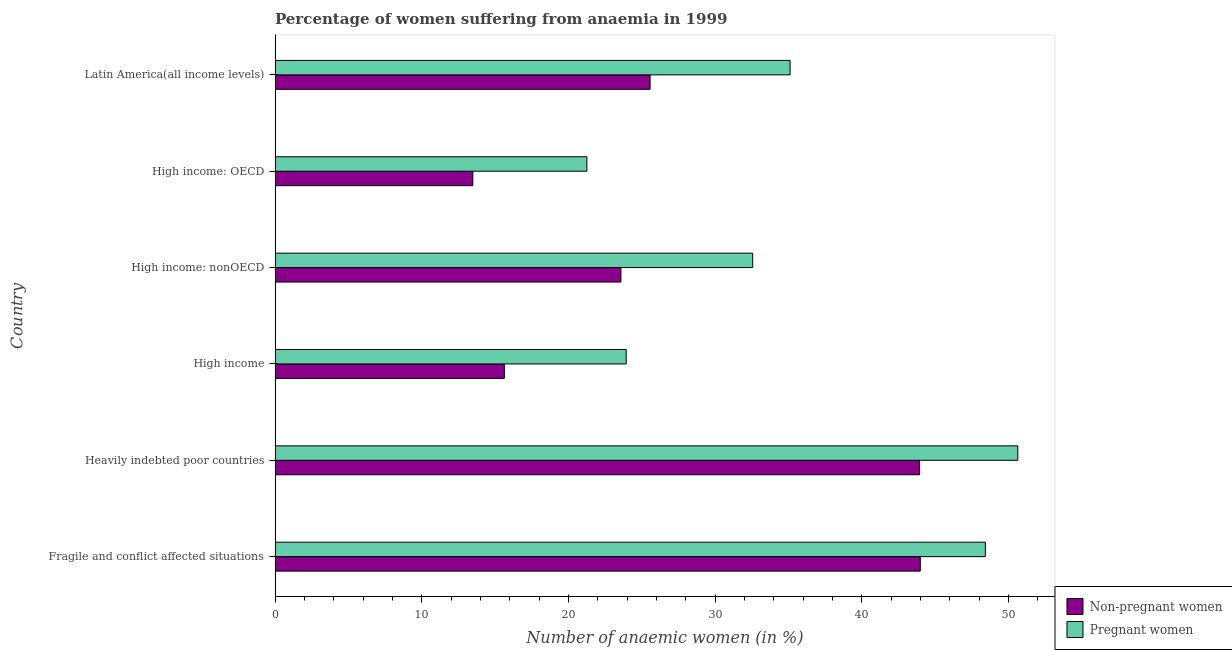How many groups of bars are there?
Make the answer very short. 6. Are the number of bars on each tick of the Y-axis equal?
Provide a short and direct response. Yes. What is the label of the 5th group of bars from the top?
Your response must be concise. Heavily indebted poor countries. What is the percentage of pregnant anaemic women in High income: OECD?
Your response must be concise. 21.26. Across all countries, what is the maximum percentage of non-pregnant anaemic women?
Make the answer very short. 44. Across all countries, what is the minimum percentage of pregnant anaemic women?
Give a very brief answer. 21.26. In which country was the percentage of pregnant anaemic women maximum?
Keep it short and to the point. Heavily indebted poor countries. In which country was the percentage of pregnant anaemic women minimum?
Offer a very short reply. High income: OECD. What is the total percentage of pregnant anaemic women in the graph?
Provide a succinct answer. 211.97. What is the difference between the percentage of pregnant anaemic women in Fragile and conflict affected situations and that in High income: nonOECD?
Your response must be concise. 15.87. What is the difference between the percentage of non-pregnant anaemic women in Heavily indebted poor countries and the percentage of pregnant anaemic women in Fragile and conflict affected situations?
Provide a short and direct response. -4.48. What is the average percentage of pregnant anaemic women per country?
Ensure brevity in your answer.  35.33. What is the difference between the percentage of non-pregnant anaemic women and percentage of pregnant anaemic women in High income: OECD?
Offer a very short reply. -7.78. In how many countries, is the percentage of non-pregnant anaemic women greater than 44 %?
Provide a succinct answer. 0. What is the ratio of the percentage of pregnant anaemic women in High income to that in Latin America(all income levels)?
Your answer should be very brief. 0.68. Is the percentage of pregnant anaemic women in Fragile and conflict affected situations less than that in Heavily indebted poor countries?
Offer a terse response. Yes. What is the difference between the highest and the second highest percentage of non-pregnant anaemic women?
Give a very brief answer. 0.05. What is the difference between the highest and the lowest percentage of pregnant anaemic women?
Your response must be concise. 29.39. In how many countries, is the percentage of non-pregnant anaemic women greater than the average percentage of non-pregnant anaemic women taken over all countries?
Your response must be concise. 2. What does the 2nd bar from the top in High income: OECD represents?
Ensure brevity in your answer.  Non-pregnant women. What does the 1st bar from the bottom in High income: nonOECD represents?
Keep it short and to the point. Non-pregnant women. How many bars are there?
Ensure brevity in your answer.  12. How many countries are there in the graph?
Offer a very short reply. 6. What is the difference between two consecutive major ticks on the X-axis?
Give a very brief answer. 10. Are the values on the major ticks of X-axis written in scientific E-notation?
Offer a terse response. No. Does the graph contain grids?
Your answer should be compact. No. Where does the legend appear in the graph?
Keep it short and to the point. Bottom right. How are the legend labels stacked?
Keep it short and to the point. Vertical. What is the title of the graph?
Provide a succinct answer. Percentage of women suffering from anaemia in 1999. Does "Secondary" appear as one of the legend labels in the graph?
Ensure brevity in your answer.  No. What is the label or title of the X-axis?
Ensure brevity in your answer.  Number of anaemic women (in %). What is the Number of anaemic women (in %) in Non-pregnant women in Fragile and conflict affected situations?
Give a very brief answer. 44. What is the Number of anaemic women (in %) in Pregnant women in Fragile and conflict affected situations?
Provide a short and direct response. 48.43. What is the Number of anaemic women (in %) in Non-pregnant women in Heavily indebted poor countries?
Give a very brief answer. 43.95. What is the Number of anaemic women (in %) in Pregnant women in Heavily indebted poor countries?
Make the answer very short. 50.65. What is the Number of anaemic women (in %) in Non-pregnant women in High income?
Make the answer very short. 15.63. What is the Number of anaemic women (in %) of Pregnant women in High income?
Your response must be concise. 23.94. What is the Number of anaemic women (in %) of Non-pregnant women in High income: nonOECD?
Give a very brief answer. 23.58. What is the Number of anaemic women (in %) in Pregnant women in High income: nonOECD?
Make the answer very short. 32.57. What is the Number of anaemic women (in %) of Non-pregnant women in High income: OECD?
Make the answer very short. 13.48. What is the Number of anaemic women (in %) in Pregnant women in High income: OECD?
Offer a very short reply. 21.26. What is the Number of anaemic women (in %) of Non-pregnant women in Latin America(all income levels)?
Offer a terse response. 25.57. What is the Number of anaemic women (in %) in Pregnant women in Latin America(all income levels)?
Make the answer very short. 35.12. Across all countries, what is the maximum Number of anaemic women (in %) in Non-pregnant women?
Provide a succinct answer. 44. Across all countries, what is the maximum Number of anaemic women (in %) of Pregnant women?
Keep it short and to the point. 50.65. Across all countries, what is the minimum Number of anaemic women (in %) of Non-pregnant women?
Provide a succinct answer. 13.48. Across all countries, what is the minimum Number of anaemic women (in %) in Pregnant women?
Provide a succinct answer. 21.26. What is the total Number of anaemic women (in %) of Non-pregnant women in the graph?
Make the answer very short. 166.22. What is the total Number of anaemic women (in %) of Pregnant women in the graph?
Offer a very short reply. 211.97. What is the difference between the Number of anaemic women (in %) of Non-pregnant women in Fragile and conflict affected situations and that in Heavily indebted poor countries?
Make the answer very short. 0.05. What is the difference between the Number of anaemic women (in %) of Pregnant women in Fragile and conflict affected situations and that in Heavily indebted poor countries?
Give a very brief answer. -2.21. What is the difference between the Number of anaemic women (in %) of Non-pregnant women in Fragile and conflict affected situations and that in High income?
Your answer should be compact. 28.36. What is the difference between the Number of anaemic women (in %) of Pregnant women in Fragile and conflict affected situations and that in High income?
Ensure brevity in your answer.  24.49. What is the difference between the Number of anaemic women (in %) of Non-pregnant women in Fragile and conflict affected situations and that in High income: nonOECD?
Keep it short and to the point. 20.41. What is the difference between the Number of anaemic women (in %) of Pregnant women in Fragile and conflict affected situations and that in High income: nonOECD?
Offer a very short reply. 15.86. What is the difference between the Number of anaemic women (in %) of Non-pregnant women in Fragile and conflict affected situations and that in High income: OECD?
Make the answer very short. 30.51. What is the difference between the Number of anaemic women (in %) of Pregnant women in Fragile and conflict affected situations and that in High income: OECD?
Your answer should be very brief. 27.17. What is the difference between the Number of anaemic women (in %) in Non-pregnant women in Fragile and conflict affected situations and that in Latin America(all income levels)?
Your response must be concise. 18.43. What is the difference between the Number of anaemic women (in %) in Pregnant women in Fragile and conflict affected situations and that in Latin America(all income levels)?
Your answer should be very brief. 13.31. What is the difference between the Number of anaemic women (in %) in Non-pregnant women in Heavily indebted poor countries and that in High income?
Offer a very short reply. 28.32. What is the difference between the Number of anaemic women (in %) in Pregnant women in Heavily indebted poor countries and that in High income?
Make the answer very short. 26.71. What is the difference between the Number of anaemic women (in %) of Non-pregnant women in Heavily indebted poor countries and that in High income: nonOECD?
Your answer should be very brief. 20.37. What is the difference between the Number of anaemic women (in %) in Pregnant women in Heavily indebted poor countries and that in High income: nonOECD?
Give a very brief answer. 18.08. What is the difference between the Number of anaemic women (in %) in Non-pregnant women in Heavily indebted poor countries and that in High income: OECD?
Offer a terse response. 30.47. What is the difference between the Number of anaemic women (in %) of Pregnant women in Heavily indebted poor countries and that in High income: OECD?
Offer a very short reply. 29.39. What is the difference between the Number of anaemic women (in %) of Non-pregnant women in Heavily indebted poor countries and that in Latin America(all income levels)?
Give a very brief answer. 18.38. What is the difference between the Number of anaemic women (in %) of Pregnant women in Heavily indebted poor countries and that in Latin America(all income levels)?
Provide a succinct answer. 15.53. What is the difference between the Number of anaemic women (in %) in Non-pregnant women in High income and that in High income: nonOECD?
Provide a succinct answer. -7.95. What is the difference between the Number of anaemic women (in %) in Pregnant women in High income and that in High income: nonOECD?
Offer a very short reply. -8.63. What is the difference between the Number of anaemic women (in %) of Non-pregnant women in High income and that in High income: OECD?
Your response must be concise. 2.15. What is the difference between the Number of anaemic women (in %) of Pregnant women in High income and that in High income: OECD?
Your response must be concise. 2.68. What is the difference between the Number of anaemic women (in %) in Non-pregnant women in High income and that in Latin America(all income levels)?
Provide a succinct answer. -9.94. What is the difference between the Number of anaemic women (in %) of Pregnant women in High income and that in Latin America(all income levels)?
Provide a succinct answer. -11.18. What is the difference between the Number of anaemic women (in %) of Non-pregnant women in High income: nonOECD and that in High income: OECD?
Make the answer very short. 10.1. What is the difference between the Number of anaemic women (in %) in Pregnant women in High income: nonOECD and that in High income: OECD?
Keep it short and to the point. 11.31. What is the difference between the Number of anaemic women (in %) of Non-pregnant women in High income: nonOECD and that in Latin America(all income levels)?
Keep it short and to the point. -1.99. What is the difference between the Number of anaemic women (in %) of Pregnant women in High income: nonOECD and that in Latin America(all income levels)?
Your answer should be very brief. -2.55. What is the difference between the Number of anaemic women (in %) in Non-pregnant women in High income: OECD and that in Latin America(all income levels)?
Offer a terse response. -12.09. What is the difference between the Number of anaemic women (in %) of Pregnant women in High income: OECD and that in Latin America(all income levels)?
Provide a short and direct response. -13.86. What is the difference between the Number of anaemic women (in %) in Non-pregnant women in Fragile and conflict affected situations and the Number of anaemic women (in %) in Pregnant women in Heavily indebted poor countries?
Your answer should be compact. -6.65. What is the difference between the Number of anaemic women (in %) in Non-pregnant women in Fragile and conflict affected situations and the Number of anaemic women (in %) in Pregnant women in High income?
Give a very brief answer. 20.05. What is the difference between the Number of anaemic women (in %) in Non-pregnant women in Fragile and conflict affected situations and the Number of anaemic women (in %) in Pregnant women in High income: nonOECD?
Provide a succinct answer. 11.43. What is the difference between the Number of anaemic women (in %) in Non-pregnant women in Fragile and conflict affected situations and the Number of anaemic women (in %) in Pregnant women in High income: OECD?
Your answer should be compact. 22.74. What is the difference between the Number of anaemic women (in %) of Non-pregnant women in Fragile and conflict affected situations and the Number of anaemic women (in %) of Pregnant women in Latin America(all income levels)?
Keep it short and to the point. 8.88. What is the difference between the Number of anaemic women (in %) of Non-pregnant women in Heavily indebted poor countries and the Number of anaemic women (in %) of Pregnant women in High income?
Provide a succinct answer. 20.01. What is the difference between the Number of anaemic women (in %) of Non-pregnant women in Heavily indebted poor countries and the Number of anaemic women (in %) of Pregnant women in High income: nonOECD?
Make the answer very short. 11.38. What is the difference between the Number of anaemic women (in %) of Non-pregnant women in Heavily indebted poor countries and the Number of anaemic women (in %) of Pregnant women in High income: OECD?
Make the answer very short. 22.69. What is the difference between the Number of anaemic women (in %) in Non-pregnant women in Heavily indebted poor countries and the Number of anaemic women (in %) in Pregnant women in Latin America(all income levels)?
Offer a terse response. 8.83. What is the difference between the Number of anaemic women (in %) in Non-pregnant women in High income and the Number of anaemic women (in %) in Pregnant women in High income: nonOECD?
Offer a very short reply. -16.94. What is the difference between the Number of anaemic women (in %) in Non-pregnant women in High income and the Number of anaemic women (in %) in Pregnant women in High income: OECD?
Your answer should be compact. -5.63. What is the difference between the Number of anaemic women (in %) of Non-pregnant women in High income and the Number of anaemic women (in %) of Pregnant women in Latin America(all income levels)?
Make the answer very short. -19.49. What is the difference between the Number of anaemic women (in %) in Non-pregnant women in High income: nonOECD and the Number of anaemic women (in %) in Pregnant women in High income: OECD?
Keep it short and to the point. 2.32. What is the difference between the Number of anaemic women (in %) of Non-pregnant women in High income: nonOECD and the Number of anaemic women (in %) of Pregnant women in Latin America(all income levels)?
Ensure brevity in your answer.  -11.54. What is the difference between the Number of anaemic women (in %) of Non-pregnant women in High income: OECD and the Number of anaemic women (in %) of Pregnant women in Latin America(all income levels)?
Offer a very short reply. -21.64. What is the average Number of anaemic women (in %) of Non-pregnant women per country?
Offer a terse response. 27.7. What is the average Number of anaemic women (in %) in Pregnant women per country?
Make the answer very short. 35.33. What is the difference between the Number of anaemic women (in %) in Non-pregnant women and Number of anaemic women (in %) in Pregnant women in Fragile and conflict affected situations?
Make the answer very short. -4.44. What is the difference between the Number of anaemic women (in %) in Non-pregnant women and Number of anaemic women (in %) in Pregnant women in Heavily indebted poor countries?
Make the answer very short. -6.7. What is the difference between the Number of anaemic women (in %) of Non-pregnant women and Number of anaemic women (in %) of Pregnant women in High income?
Offer a terse response. -8.31. What is the difference between the Number of anaemic women (in %) in Non-pregnant women and Number of anaemic women (in %) in Pregnant women in High income: nonOECD?
Provide a short and direct response. -8.99. What is the difference between the Number of anaemic women (in %) in Non-pregnant women and Number of anaemic women (in %) in Pregnant women in High income: OECD?
Provide a short and direct response. -7.78. What is the difference between the Number of anaemic women (in %) of Non-pregnant women and Number of anaemic women (in %) of Pregnant women in Latin America(all income levels)?
Give a very brief answer. -9.55. What is the ratio of the Number of anaemic women (in %) of Non-pregnant women in Fragile and conflict affected situations to that in Heavily indebted poor countries?
Your answer should be compact. 1. What is the ratio of the Number of anaemic women (in %) in Pregnant women in Fragile and conflict affected situations to that in Heavily indebted poor countries?
Provide a succinct answer. 0.96. What is the ratio of the Number of anaemic women (in %) in Non-pregnant women in Fragile and conflict affected situations to that in High income?
Keep it short and to the point. 2.81. What is the ratio of the Number of anaemic women (in %) in Pregnant women in Fragile and conflict affected situations to that in High income?
Your response must be concise. 2.02. What is the ratio of the Number of anaemic women (in %) of Non-pregnant women in Fragile and conflict affected situations to that in High income: nonOECD?
Your answer should be very brief. 1.87. What is the ratio of the Number of anaemic women (in %) of Pregnant women in Fragile and conflict affected situations to that in High income: nonOECD?
Your response must be concise. 1.49. What is the ratio of the Number of anaemic women (in %) of Non-pregnant women in Fragile and conflict affected situations to that in High income: OECD?
Make the answer very short. 3.26. What is the ratio of the Number of anaemic women (in %) in Pregnant women in Fragile and conflict affected situations to that in High income: OECD?
Your answer should be very brief. 2.28. What is the ratio of the Number of anaemic women (in %) in Non-pregnant women in Fragile and conflict affected situations to that in Latin America(all income levels)?
Offer a very short reply. 1.72. What is the ratio of the Number of anaemic women (in %) of Pregnant women in Fragile and conflict affected situations to that in Latin America(all income levels)?
Make the answer very short. 1.38. What is the ratio of the Number of anaemic women (in %) in Non-pregnant women in Heavily indebted poor countries to that in High income?
Your response must be concise. 2.81. What is the ratio of the Number of anaemic women (in %) of Pregnant women in Heavily indebted poor countries to that in High income?
Your response must be concise. 2.12. What is the ratio of the Number of anaemic women (in %) of Non-pregnant women in Heavily indebted poor countries to that in High income: nonOECD?
Your response must be concise. 1.86. What is the ratio of the Number of anaemic women (in %) in Pregnant women in Heavily indebted poor countries to that in High income: nonOECD?
Your answer should be very brief. 1.56. What is the ratio of the Number of anaemic women (in %) of Non-pregnant women in Heavily indebted poor countries to that in High income: OECD?
Ensure brevity in your answer.  3.26. What is the ratio of the Number of anaemic women (in %) of Pregnant women in Heavily indebted poor countries to that in High income: OECD?
Make the answer very short. 2.38. What is the ratio of the Number of anaemic women (in %) of Non-pregnant women in Heavily indebted poor countries to that in Latin America(all income levels)?
Offer a terse response. 1.72. What is the ratio of the Number of anaemic women (in %) of Pregnant women in Heavily indebted poor countries to that in Latin America(all income levels)?
Your answer should be very brief. 1.44. What is the ratio of the Number of anaemic women (in %) of Non-pregnant women in High income to that in High income: nonOECD?
Offer a very short reply. 0.66. What is the ratio of the Number of anaemic women (in %) of Pregnant women in High income to that in High income: nonOECD?
Offer a terse response. 0.74. What is the ratio of the Number of anaemic women (in %) of Non-pregnant women in High income to that in High income: OECD?
Provide a short and direct response. 1.16. What is the ratio of the Number of anaemic women (in %) of Pregnant women in High income to that in High income: OECD?
Ensure brevity in your answer.  1.13. What is the ratio of the Number of anaemic women (in %) of Non-pregnant women in High income to that in Latin America(all income levels)?
Your response must be concise. 0.61. What is the ratio of the Number of anaemic women (in %) in Pregnant women in High income to that in Latin America(all income levels)?
Keep it short and to the point. 0.68. What is the ratio of the Number of anaemic women (in %) of Non-pregnant women in High income: nonOECD to that in High income: OECD?
Make the answer very short. 1.75. What is the ratio of the Number of anaemic women (in %) of Pregnant women in High income: nonOECD to that in High income: OECD?
Provide a short and direct response. 1.53. What is the ratio of the Number of anaemic women (in %) in Non-pregnant women in High income: nonOECD to that in Latin America(all income levels)?
Provide a short and direct response. 0.92. What is the ratio of the Number of anaemic women (in %) of Pregnant women in High income: nonOECD to that in Latin America(all income levels)?
Provide a short and direct response. 0.93. What is the ratio of the Number of anaemic women (in %) in Non-pregnant women in High income: OECD to that in Latin America(all income levels)?
Provide a short and direct response. 0.53. What is the ratio of the Number of anaemic women (in %) in Pregnant women in High income: OECD to that in Latin America(all income levels)?
Your response must be concise. 0.61. What is the difference between the highest and the second highest Number of anaemic women (in %) of Non-pregnant women?
Ensure brevity in your answer.  0.05. What is the difference between the highest and the second highest Number of anaemic women (in %) of Pregnant women?
Give a very brief answer. 2.21. What is the difference between the highest and the lowest Number of anaemic women (in %) in Non-pregnant women?
Keep it short and to the point. 30.51. What is the difference between the highest and the lowest Number of anaemic women (in %) of Pregnant women?
Make the answer very short. 29.39. 